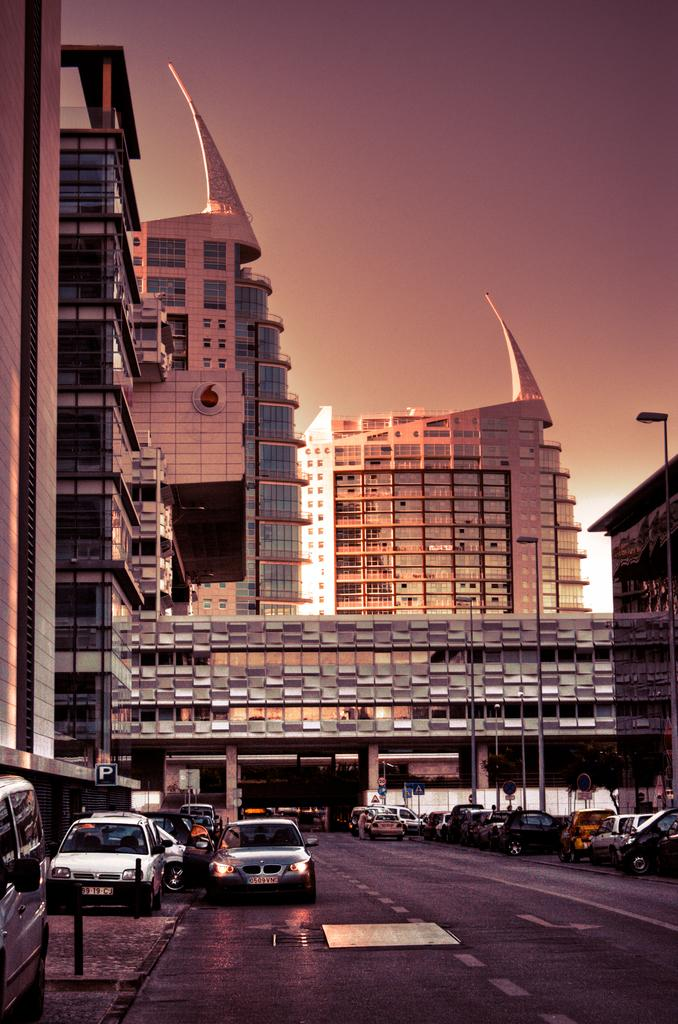What type of structures can be seen in the image? There are buildings in the image. What type of lighting is present along the road in the image? Street lights are present in the image. What type of information might be conveyed by the signs in the image? Sign boards are visible in the image, which might convey information such as directions or advertisements. What type of transportation is present on the road in the image? There are vehicles on the road in the image. What can be seen in the background of the image? The sky is visible in the background of the image. What is the current time of day in the image? The time of day cannot be determined from the image alone, as it only shows buildings, street lights, sign boards, vehicles, and the sky. What is the condition of the road in the image? The condition of the road cannot be determined from the image alone, as it only shows vehicles on the road and not the road surface itself. 